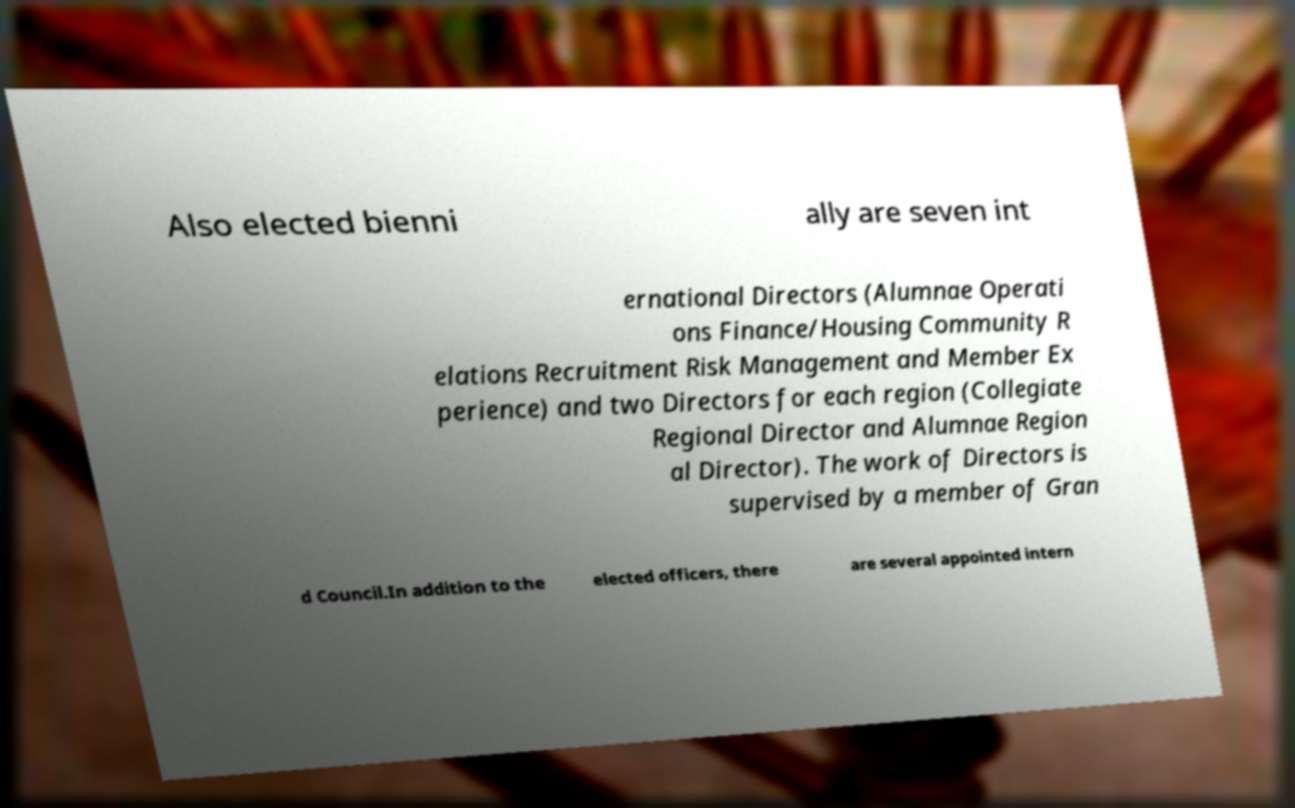Please identify and transcribe the text found in this image. Also elected bienni ally are seven int ernational Directors (Alumnae Operati ons Finance/Housing Community R elations Recruitment Risk Management and Member Ex perience) and two Directors for each region (Collegiate Regional Director and Alumnae Region al Director). The work of Directors is supervised by a member of Gran d Council.In addition to the elected officers, there are several appointed intern 